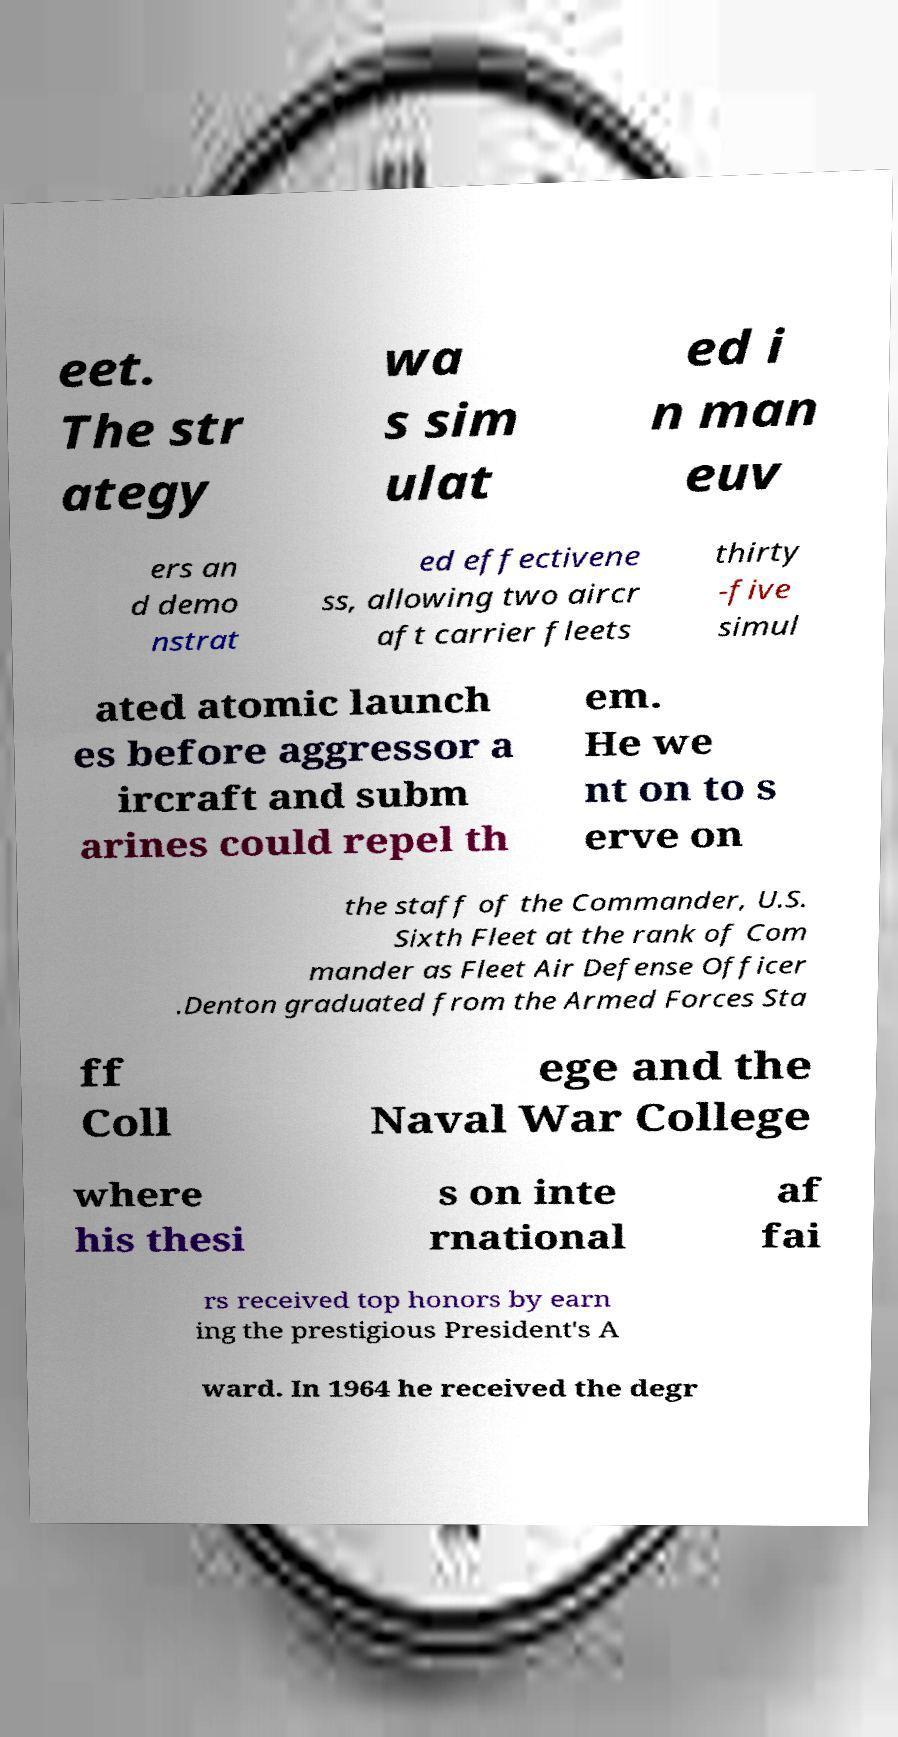I need the written content from this picture converted into text. Can you do that? eet. The str ategy wa s sim ulat ed i n man euv ers an d demo nstrat ed effectivene ss, allowing two aircr aft carrier fleets thirty -five simul ated atomic launch es before aggressor a ircraft and subm arines could repel th em. He we nt on to s erve on the staff of the Commander, U.S. Sixth Fleet at the rank of Com mander as Fleet Air Defense Officer .Denton graduated from the Armed Forces Sta ff Coll ege and the Naval War College where his thesi s on inte rnational af fai rs received top honors by earn ing the prestigious President's A ward. In 1964 he received the degr 